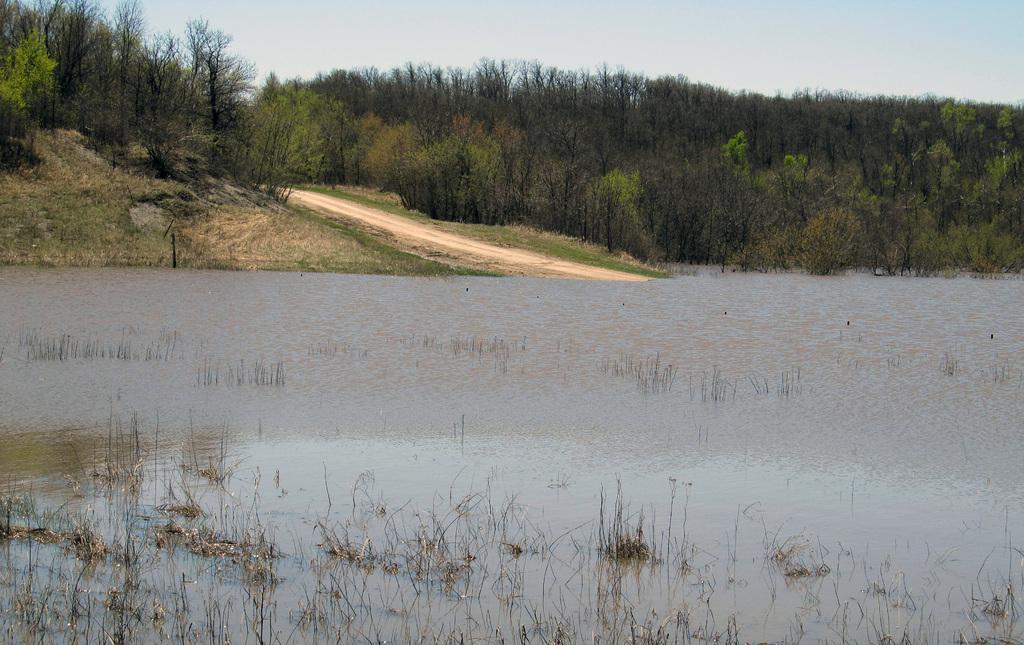Can you describe this image briefly? In this image I can see at the bottom it looks like a pond. In the middle there are trees, at the top it is the sky. 